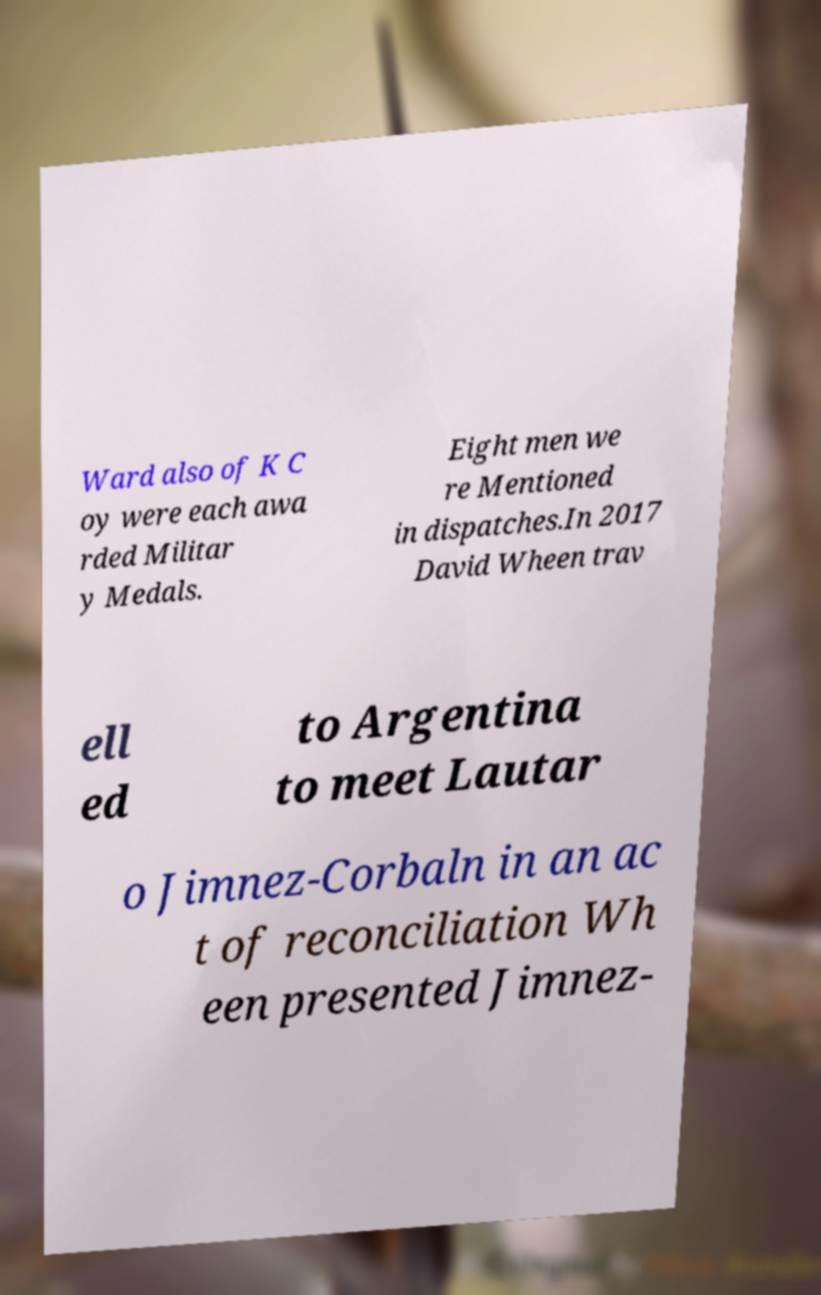Can you accurately transcribe the text from the provided image for me? Ward also of K C oy were each awa rded Militar y Medals. Eight men we re Mentioned in dispatches.In 2017 David Wheen trav ell ed to Argentina to meet Lautar o Jimnez-Corbaln in an ac t of reconciliation Wh een presented Jimnez- 